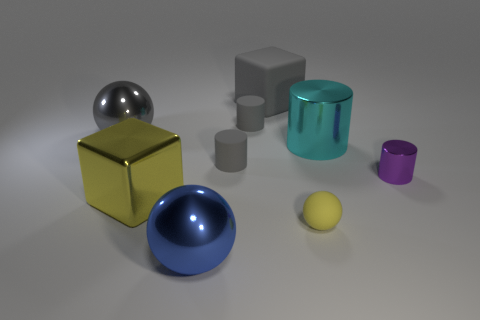Subtract all red cylinders. Subtract all brown balls. How many cylinders are left? 4 Add 1 big green things. How many objects exist? 10 Subtract all balls. How many objects are left? 6 Add 5 big green metallic cubes. How many big green metallic cubes exist? 5 Subtract 0 green balls. How many objects are left? 9 Subtract all tiny balls. Subtract all small matte cylinders. How many objects are left? 6 Add 2 big gray metallic objects. How many big gray metallic objects are left? 3 